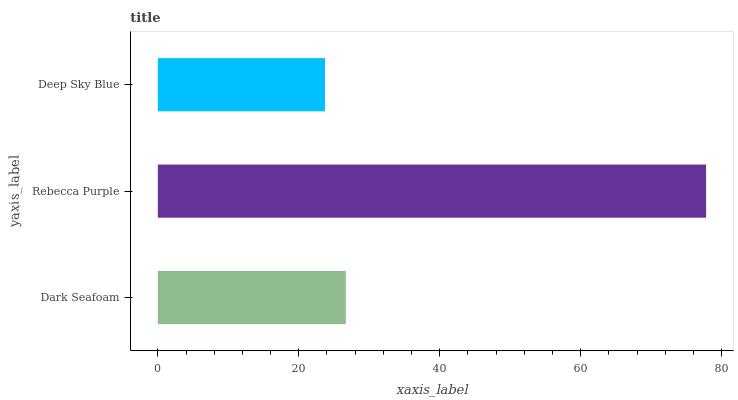Is Deep Sky Blue the minimum?
Answer yes or no. Yes. Is Rebecca Purple the maximum?
Answer yes or no. Yes. Is Rebecca Purple the minimum?
Answer yes or no. No. Is Deep Sky Blue the maximum?
Answer yes or no. No. Is Rebecca Purple greater than Deep Sky Blue?
Answer yes or no. Yes. Is Deep Sky Blue less than Rebecca Purple?
Answer yes or no. Yes. Is Deep Sky Blue greater than Rebecca Purple?
Answer yes or no. No. Is Rebecca Purple less than Deep Sky Blue?
Answer yes or no. No. Is Dark Seafoam the high median?
Answer yes or no. Yes. Is Dark Seafoam the low median?
Answer yes or no. Yes. Is Rebecca Purple the high median?
Answer yes or no. No. Is Rebecca Purple the low median?
Answer yes or no. No. 